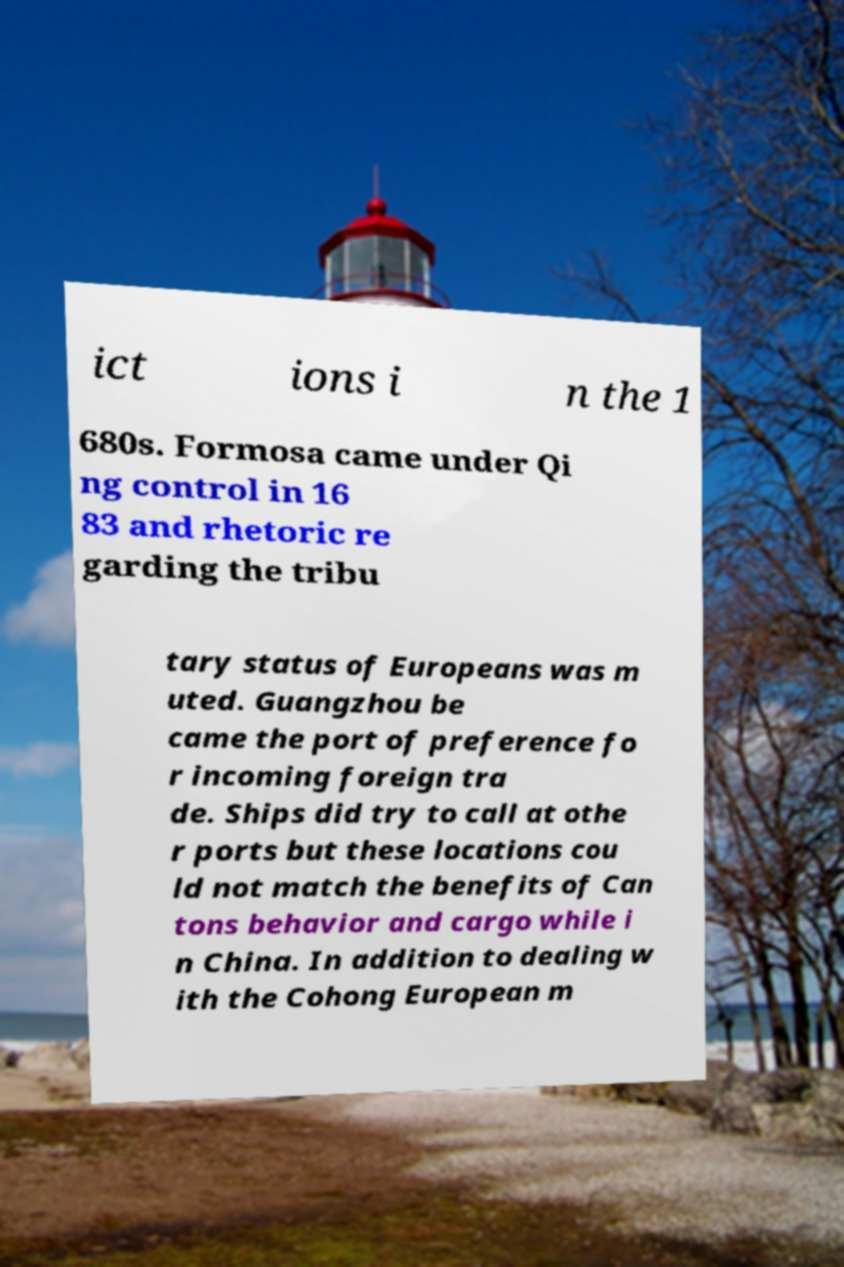What messages or text are displayed in this image? I need them in a readable, typed format. ict ions i n the 1 680s. Formosa came under Qi ng control in 16 83 and rhetoric re garding the tribu tary status of Europeans was m uted. Guangzhou be came the port of preference fo r incoming foreign tra de. Ships did try to call at othe r ports but these locations cou ld not match the benefits of Can tons behavior and cargo while i n China. In addition to dealing w ith the Cohong European m 